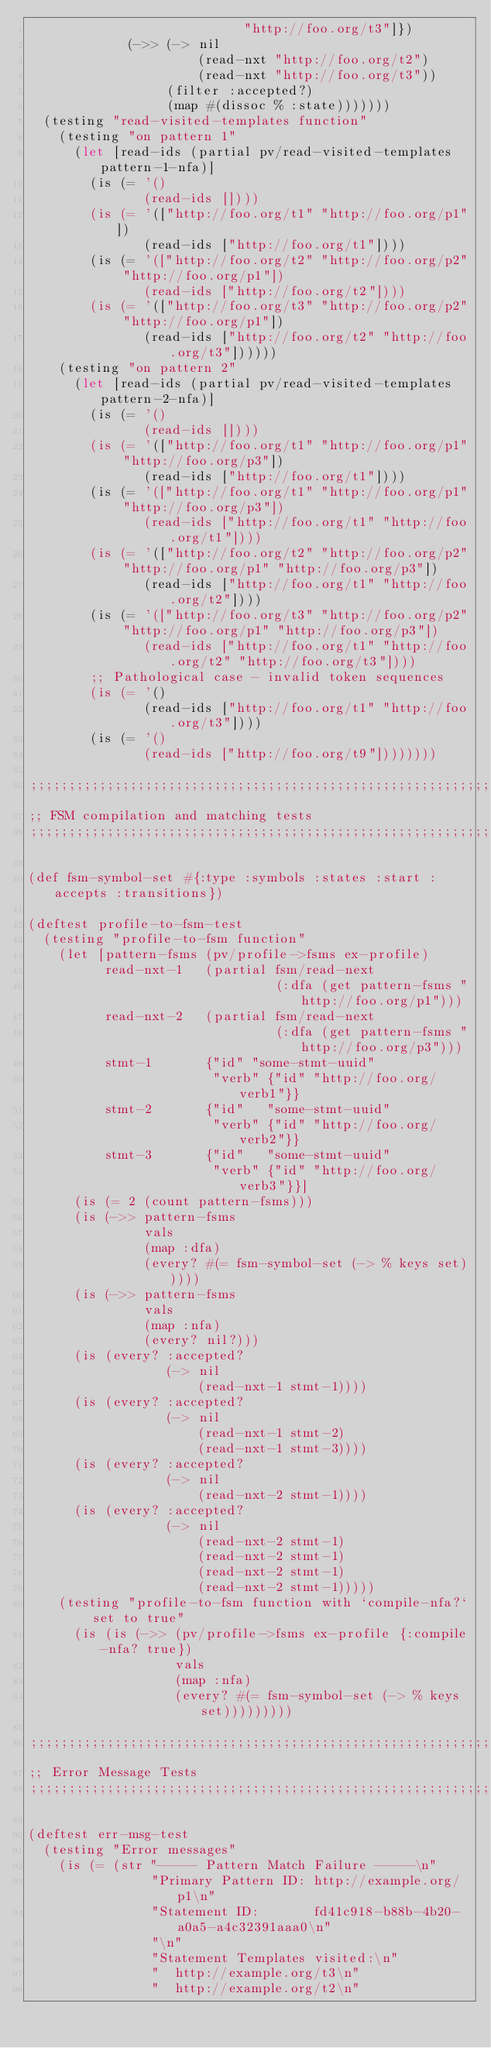Convert code to text. <code><loc_0><loc_0><loc_500><loc_500><_Clojure_>                            "http://foo.org/t3"]})
             (->> (-> nil
                      (read-nxt "http://foo.org/t2")
                      (read-nxt "http://foo.org/t3"))
                  (filter :accepted?)
                  (map #(dissoc % :state)))))))
  (testing "read-visited-templates function"
    (testing "on pattern 1"
      (let [read-ids (partial pv/read-visited-templates pattern-1-nfa)]
        (is (= '()
               (read-ids [])))
        (is (= '(["http://foo.org/t1" "http://foo.org/p1"])
               (read-ids ["http://foo.org/t1"])))
        (is (= '(["http://foo.org/t2" "http://foo.org/p2" "http://foo.org/p1"])
               (read-ids ["http://foo.org/t2"])))
        (is (= '(["http://foo.org/t3" "http://foo.org/p2" "http://foo.org/p1"])
               (read-ids ["http://foo.org/t2" "http://foo.org/t3"])))))
    (testing "on pattern 2"
      (let [read-ids (partial pv/read-visited-templates pattern-2-nfa)]
        (is (= '()
               (read-ids [])))
        (is (= '(["http://foo.org/t1" "http://foo.org/p1" "http://foo.org/p3"])
               (read-ids ["http://foo.org/t1"])))
        (is (= '(["http://foo.org/t1" "http://foo.org/p1" "http://foo.org/p3"])
               (read-ids ["http://foo.org/t1" "http://foo.org/t1"])))
        (is (= '(["http://foo.org/t2" "http://foo.org/p2" "http://foo.org/p1" "http://foo.org/p3"])
               (read-ids ["http://foo.org/t1" "http://foo.org/t2"])))
        (is (= '(["http://foo.org/t3" "http://foo.org/p2" "http://foo.org/p1" "http://foo.org/p3"])
               (read-ids ["http://foo.org/t1" "http://foo.org/t2" "http://foo.org/t3"])))
        ;; Pathological case - invalid token sequences
        (is (= '()
               (read-ids ["http://foo.org/t1" "http://foo.org/t3"])))
        (is (= '()
               (read-ids ["http://foo.org/t9"])))))))

;;;;;;;;;;;;;;;;;;;;;;;;;;;;;;;;;;;;;;;;;;;;;;;;;;;;;;;;;;;;;;;;;;;;;;;;;;;;;;;
;; FSM compilation and matching tests
;;;;;;;;;;;;;;;;;;;;;;;;;;;;;;;;;;;;;;;;;;;;;;;;;;;;;;;;;;;;;;;;;;;;;;;;;;;;;;;

(def fsm-symbol-set #{:type :symbols :states :start :accepts :transitions})

(deftest profile-to-fsm-test
  (testing "profile-to-fsm function"
    (let [pattern-fsms (pv/profile->fsms ex-profile)
          read-nxt-1   (partial fsm/read-next
                                (:dfa (get pattern-fsms "http://foo.org/p1")))
          read-nxt-2   (partial fsm/read-next
                                (:dfa (get pattern-fsms "http://foo.org/p3")))
          stmt-1       {"id" "some-stmt-uuid"
                        "verb" {"id" "http://foo.org/verb1"}}
          stmt-2       {"id"   "some-stmt-uuid"
                        "verb" {"id" "http://foo.org/verb2"}}
          stmt-3       {"id"   "some-stmt-uuid"
                        "verb" {"id" "http://foo.org/verb3"}}]
      (is (= 2 (count pattern-fsms)))
      (is (->> pattern-fsms
               vals
               (map :dfa)
               (every? #(= fsm-symbol-set (-> % keys set)))))
      (is (->> pattern-fsms
               vals
               (map :nfa)
               (every? nil?)))
      (is (every? :accepted?
                  (-> nil
                      (read-nxt-1 stmt-1))))
      (is (every? :accepted?
                  (-> nil
                      (read-nxt-1 stmt-2)
                      (read-nxt-1 stmt-3))))
      (is (every? :accepted?
                  (-> nil
                      (read-nxt-2 stmt-1))))
      (is (every? :accepted?
                  (-> nil
                      (read-nxt-2 stmt-1)
                      (read-nxt-2 stmt-1)
                      (read-nxt-2 stmt-1)
                      (read-nxt-2 stmt-1)))))
    (testing "profile-to-fsm function with `compile-nfa?` set to true"
      (is (is (->> (pv/profile->fsms ex-profile {:compile-nfa? true})
                   vals
                   (map :nfa)
                   (every? #(= fsm-symbol-set (-> % keys set)))))))))

;;;;;;;;;;;;;;;;;;;;;;;;;;;;;;;;;;;;;;;;;;;;;;;;;;;;;;;;;;;;;;;;;;;;;;;;;;;;;;;
;; Error Message Tests
;;;;;;;;;;;;;;;;;;;;;;;;;;;;;;;;;;;;;;;;;;;;;;;;;;;;;;;;;;;;;;;;;;;;;;;;;;;;;;;

(deftest err-msg-test
  (testing "Error messages"
    (is (= (str "----- Pattern Match Failure -----\n"
                "Primary Pattern ID: http://example.org/p1\n"
                "Statement ID:       fd41c918-b88b-4b20-a0a5-a4c32391aaa0\n"
                "\n"
                "Statement Templates visited:\n"
                "  http://example.org/t3\n"
                "  http://example.org/t2\n"</code> 